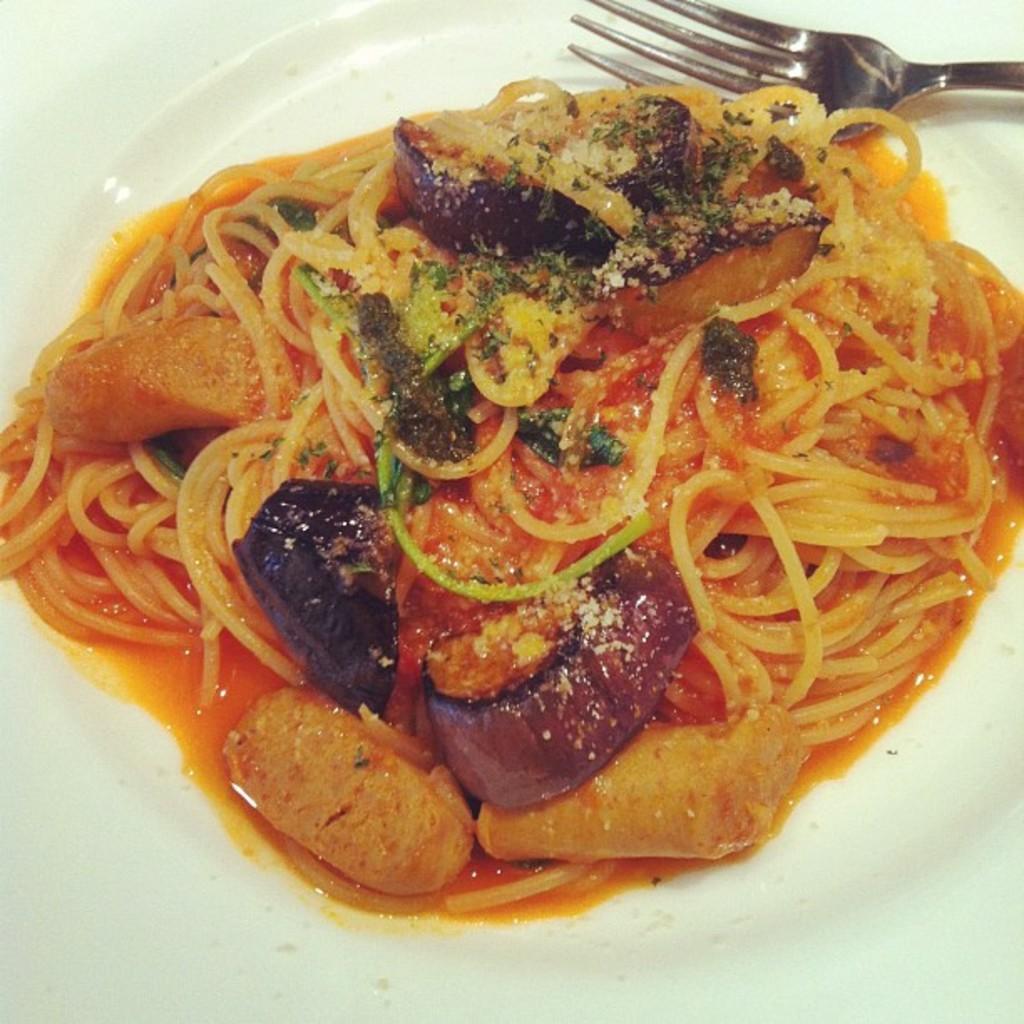Can you describe this image briefly? In this image I can see a plate which consists of some food item and fork. 